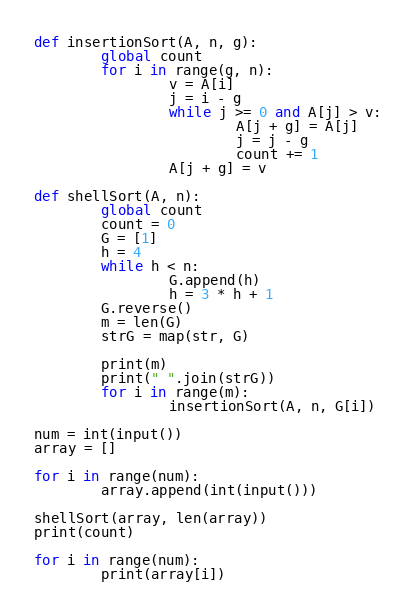Convert code to text. <code><loc_0><loc_0><loc_500><loc_500><_Python_>def insertionSort(A, n, g):
        global count
        for i in range(g, n):
                v = A[i]
                j = i - g
                while j >= 0 and A[j] > v:
                        A[j + g] = A[j]
                        j = j - g
                        count += 1
                A[j + g] = v

def shellSort(A, n):
        global count
        count = 0
        G = [1]
        h = 4
        while h < n:
                G.append(h)
                h = 3 * h + 1
        G.reverse()
        m = len(G)
        strG = map(str, G)

        print(m)
        print(" ".join(strG))
        for i in range(m):
                insertionSort(A, n, G[i])

num = int(input())
array = []

for i in range(num):
        array.append(int(input()))

shellSort(array, len(array))
print(count)

for i in range(num):
        print(array[i])
</code> 